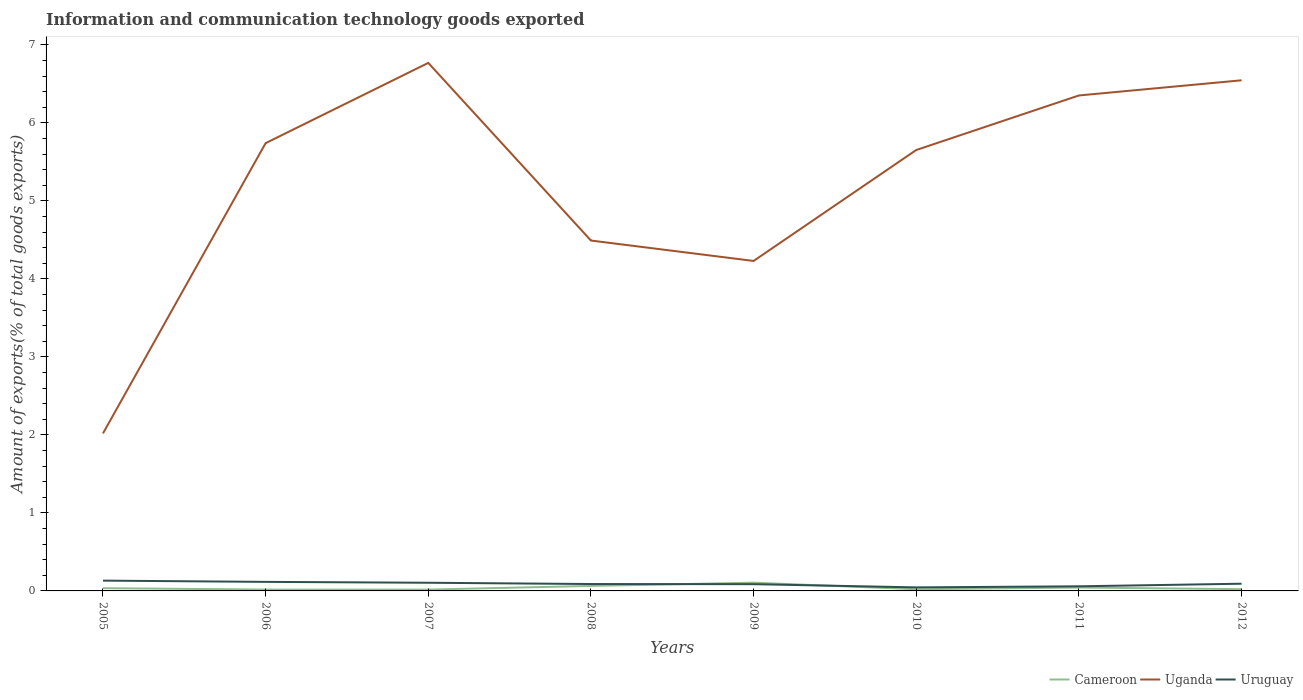How many different coloured lines are there?
Keep it short and to the point. 3. Does the line corresponding to Uganda intersect with the line corresponding to Uruguay?
Keep it short and to the point. No. Is the number of lines equal to the number of legend labels?
Provide a short and direct response. Yes. Across all years, what is the maximum amount of goods exported in Uruguay?
Provide a short and direct response. 0.05. In which year was the amount of goods exported in Cameroon maximum?
Ensure brevity in your answer.  2007. What is the total amount of goods exported in Cameroon in the graph?
Provide a succinct answer. 0. What is the difference between the highest and the second highest amount of goods exported in Uganda?
Make the answer very short. 4.75. What is the difference between the highest and the lowest amount of goods exported in Uruguay?
Your response must be concise. 4. Is the amount of goods exported in Cameroon strictly greater than the amount of goods exported in Uruguay over the years?
Provide a succinct answer. No. How many lines are there?
Your answer should be very brief. 3. How many years are there in the graph?
Ensure brevity in your answer.  8. Are the values on the major ticks of Y-axis written in scientific E-notation?
Your response must be concise. No. Does the graph contain grids?
Give a very brief answer. No. Where does the legend appear in the graph?
Keep it short and to the point. Bottom right. What is the title of the graph?
Your answer should be compact. Information and communication technology goods exported. What is the label or title of the Y-axis?
Ensure brevity in your answer.  Amount of exports(% of total goods exports). What is the Amount of exports(% of total goods exports) in Cameroon in 2005?
Offer a very short reply. 0.04. What is the Amount of exports(% of total goods exports) in Uganda in 2005?
Provide a short and direct response. 2.02. What is the Amount of exports(% of total goods exports) in Uruguay in 2005?
Keep it short and to the point. 0.13. What is the Amount of exports(% of total goods exports) in Cameroon in 2006?
Offer a terse response. 0.02. What is the Amount of exports(% of total goods exports) in Uganda in 2006?
Provide a succinct answer. 5.74. What is the Amount of exports(% of total goods exports) of Uruguay in 2006?
Make the answer very short. 0.12. What is the Amount of exports(% of total goods exports) of Cameroon in 2007?
Offer a terse response. 0.02. What is the Amount of exports(% of total goods exports) of Uganda in 2007?
Give a very brief answer. 6.77. What is the Amount of exports(% of total goods exports) in Uruguay in 2007?
Your answer should be very brief. 0.1. What is the Amount of exports(% of total goods exports) in Cameroon in 2008?
Your answer should be compact. 0.06. What is the Amount of exports(% of total goods exports) of Uganda in 2008?
Keep it short and to the point. 4.49. What is the Amount of exports(% of total goods exports) of Uruguay in 2008?
Make the answer very short. 0.09. What is the Amount of exports(% of total goods exports) of Cameroon in 2009?
Your answer should be compact. 0.11. What is the Amount of exports(% of total goods exports) in Uganda in 2009?
Your answer should be compact. 4.23. What is the Amount of exports(% of total goods exports) in Uruguay in 2009?
Your answer should be compact. 0.09. What is the Amount of exports(% of total goods exports) in Cameroon in 2010?
Offer a terse response. 0.02. What is the Amount of exports(% of total goods exports) of Uganda in 2010?
Give a very brief answer. 5.65. What is the Amount of exports(% of total goods exports) of Uruguay in 2010?
Offer a terse response. 0.05. What is the Amount of exports(% of total goods exports) in Cameroon in 2011?
Provide a short and direct response. 0.04. What is the Amount of exports(% of total goods exports) of Uganda in 2011?
Provide a short and direct response. 6.35. What is the Amount of exports(% of total goods exports) in Uruguay in 2011?
Your response must be concise. 0.06. What is the Amount of exports(% of total goods exports) of Cameroon in 2012?
Offer a very short reply. 0.02. What is the Amount of exports(% of total goods exports) of Uganda in 2012?
Your answer should be compact. 6.55. What is the Amount of exports(% of total goods exports) of Uruguay in 2012?
Ensure brevity in your answer.  0.09. Across all years, what is the maximum Amount of exports(% of total goods exports) in Cameroon?
Give a very brief answer. 0.11. Across all years, what is the maximum Amount of exports(% of total goods exports) in Uganda?
Provide a short and direct response. 6.77. Across all years, what is the maximum Amount of exports(% of total goods exports) of Uruguay?
Keep it short and to the point. 0.13. Across all years, what is the minimum Amount of exports(% of total goods exports) of Cameroon?
Your answer should be compact. 0.02. Across all years, what is the minimum Amount of exports(% of total goods exports) in Uganda?
Offer a terse response. 2.02. Across all years, what is the minimum Amount of exports(% of total goods exports) of Uruguay?
Your answer should be compact. 0.05. What is the total Amount of exports(% of total goods exports) in Cameroon in the graph?
Your response must be concise. 0.33. What is the total Amount of exports(% of total goods exports) of Uganda in the graph?
Your response must be concise. 41.8. What is the total Amount of exports(% of total goods exports) in Uruguay in the graph?
Offer a very short reply. 0.72. What is the difference between the Amount of exports(% of total goods exports) of Cameroon in 2005 and that in 2006?
Keep it short and to the point. 0.02. What is the difference between the Amount of exports(% of total goods exports) in Uganda in 2005 and that in 2006?
Offer a very short reply. -3.72. What is the difference between the Amount of exports(% of total goods exports) in Uruguay in 2005 and that in 2006?
Ensure brevity in your answer.  0.02. What is the difference between the Amount of exports(% of total goods exports) of Cameroon in 2005 and that in 2007?
Provide a short and direct response. 0.02. What is the difference between the Amount of exports(% of total goods exports) in Uganda in 2005 and that in 2007?
Make the answer very short. -4.75. What is the difference between the Amount of exports(% of total goods exports) in Uruguay in 2005 and that in 2007?
Offer a very short reply. 0.03. What is the difference between the Amount of exports(% of total goods exports) in Cameroon in 2005 and that in 2008?
Give a very brief answer. -0.03. What is the difference between the Amount of exports(% of total goods exports) of Uganda in 2005 and that in 2008?
Keep it short and to the point. -2.47. What is the difference between the Amount of exports(% of total goods exports) of Uruguay in 2005 and that in 2008?
Offer a very short reply. 0.04. What is the difference between the Amount of exports(% of total goods exports) in Cameroon in 2005 and that in 2009?
Keep it short and to the point. -0.07. What is the difference between the Amount of exports(% of total goods exports) of Uganda in 2005 and that in 2009?
Keep it short and to the point. -2.21. What is the difference between the Amount of exports(% of total goods exports) of Uruguay in 2005 and that in 2009?
Provide a succinct answer. 0.05. What is the difference between the Amount of exports(% of total goods exports) in Cameroon in 2005 and that in 2010?
Offer a very short reply. 0.01. What is the difference between the Amount of exports(% of total goods exports) of Uganda in 2005 and that in 2010?
Provide a short and direct response. -3.63. What is the difference between the Amount of exports(% of total goods exports) in Uruguay in 2005 and that in 2010?
Offer a terse response. 0.09. What is the difference between the Amount of exports(% of total goods exports) of Cameroon in 2005 and that in 2011?
Offer a very short reply. -0.01. What is the difference between the Amount of exports(% of total goods exports) of Uganda in 2005 and that in 2011?
Your answer should be very brief. -4.33. What is the difference between the Amount of exports(% of total goods exports) of Uruguay in 2005 and that in 2011?
Provide a short and direct response. 0.07. What is the difference between the Amount of exports(% of total goods exports) in Cameroon in 2005 and that in 2012?
Give a very brief answer. 0.01. What is the difference between the Amount of exports(% of total goods exports) in Uganda in 2005 and that in 2012?
Keep it short and to the point. -4.53. What is the difference between the Amount of exports(% of total goods exports) in Uruguay in 2005 and that in 2012?
Your response must be concise. 0.04. What is the difference between the Amount of exports(% of total goods exports) in Uganda in 2006 and that in 2007?
Offer a terse response. -1.03. What is the difference between the Amount of exports(% of total goods exports) of Uruguay in 2006 and that in 2007?
Keep it short and to the point. 0.01. What is the difference between the Amount of exports(% of total goods exports) of Cameroon in 2006 and that in 2008?
Keep it short and to the point. -0.05. What is the difference between the Amount of exports(% of total goods exports) of Uganda in 2006 and that in 2008?
Provide a succinct answer. 1.25. What is the difference between the Amount of exports(% of total goods exports) in Uruguay in 2006 and that in 2008?
Your answer should be compact. 0.03. What is the difference between the Amount of exports(% of total goods exports) in Cameroon in 2006 and that in 2009?
Give a very brief answer. -0.09. What is the difference between the Amount of exports(% of total goods exports) in Uganda in 2006 and that in 2009?
Your answer should be compact. 1.51. What is the difference between the Amount of exports(% of total goods exports) of Uruguay in 2006 and that in 2009?
Give a very brief answer. 0.03. What is the difference between the Amount of exports(% of total goods exports) in Cameroon in 2006 and that in 2010?
Ensure brevity in your answer.  -0. What is the difference between the Amount of exports(% of total goods exports) in Uganda in 2006 and that in 2010?
Offer a very short reply. 0.09. What is the difference between the Amount of exports(% of total goods exports) in Uruguay in 2006 and that in 2010?
Your response must be concise. 0.07. What is the difference between the Amount of exports(% of total goods exports) of Cameroon in 2006 and that in 2011?
Make the answer very short. -0.03. What is the difference between the Amount of exports(% of total goods exports) in Uganda in 2006 and that in 2011?
Make the answer very short. -0.61. What is the difference between the Amount of exports(% of total goods exports) of Uruguay in 2006 and that in 2011?
Offer a terse response. 0.06. What is the difference between the Amount of exports(% of total goods exports) in Cameroon in 2006 and that in 2012?
Provide a short and direct response. -0.01. What is the difference between the Amount of exports(% of total goods exports) of Uganda in 2006 and that in 2012?
Ensure brevity in your answer.  -0.81. What is the difference between the Amount of exports(% of total goods exports) of Uruguay in 2006 and that in 2012?
Keep it short and to the point. 0.02. What is the difference between the Amount of exports(% of total goods exports) of Cameroon in 2007 and that in 2008?
Keep it short and to the point. -0.05. What is the difference between the Amount of exports(% of total goods exports) in Uganda in 2007 and that in 2008?
Your response must be concise. 2.28. What is the difference between the Amount of exports(% of total goods exports) of Uruguay in 2007 and that in 2008?
Offer a terse response. 0.02. What is the difference between the Amount of exports(% of total goods exports) of Cameroon in 2007 and that in 2009?
Ensure brevity in your answer.  -0.09. What is the difference between the Amount of exports(% of total goods exports) in Uganda in 2007 and that in 2009?
Your answer should be compact. 2.54. What is the difference between the Amount of exports(% of total goods exports) of Uruguay in 2007 and that in 2009?
Make the answer very short. 0.02. What is the difference between the Amount of exports(% of total goods exports) of Cameroon in 2007 and that in 2010?
Make the answer very short. -0. What is the difference between the Amount of exports(% of total goods exports) in Uganda in 2007 and that in 2010?
Your answer should be very brief. 1.12. What is the difference between the Amount of exports(% of total goods exports) in Uruguay in 2007 and that in 2010?
Give a very brief answer. 0.06. What is the difference between the Amount of exports(% of total goods exports) of Cameroon in 2007 and that in 2011?
Offer a very short reply. -0.03. What is the difference between the Amount of exports(% of total goods exports) of Uganda in 2007 and that in 2011?
Your answer should be compact. 0.42. What is the difference between the Amount of exports(% of total goods exports) of Uruguay in 2007 and that in 2011?
Make the answer very short. 0.05. What is the difference between the Amount of exports(% of total goods exports) in Cameroon in 2007 and that in 2012?
Keep it short and to the point. -0.01. What is the difference between the Amount of exports(% of total goods exports) in Uganda in 2007 and that in 2012?
Keep it short and to the point. 0.22. What is the difference between the Amount of exports(% of total goods exports) of Uruguay in 2007 and that in 2012?
Provide a short and direct response. 0.01. What is the difference between the Amount of exports(% of total goods exports) of Cameroon in 2008 and that in 2009?
Your answer should be very brief. -0.04. What is the difference between the Amount of exports(% of total goods exports) in Uganda in 2008 and that in 2009?
Offer a terse response. 0.26. What is the difference between the Amount of exports(% of total goods exports) of Uruguay in 2008 and that in 2009?
Make the answer very short. 0. What is the difference between the Amount of exports(% of total goods exports) in Cameroon in 2008 and that in 2010?
Provide a short and direct response. 0.04. What is the difference between the Amount of exports(% of total goods exports) in Uganda in 2008 and that in 2010?
Provide a succinct answer. -1.16. What is the difference between the Amount of exports(% of total goods exports) in Uruguay in 2008 and that in 2010?
Give a very brief answer. 0.04. What is the difference between the Amount of exports(% of total goods exports) in Cameroon in 2008 and that in 2011?
Provide a succinct answer. 0.02. What is the difference between the Amount of exports(% of total goods exports) of Uganda in 2008 and that in 2011?
Your answer should be very brief. -1.86. What is the difference between the Amount of exports(% of total goods exports) of Uruguay in 2008 and that in 2011?
Provide a succinct answer. 0.03. What is the difference between the Amount of exports(% of total goods exports) of Cameroon in 2008 and that in 2012?
Ensure brevity in your answer.  0.04. What is the difference between the Amount of exports(% of total goods exports) of Uganda in 2008 and that in 2012?
Offer a very short reply. -2.05. What is the difference between the Amount of exports(% of total goods exports) in Uruguay in 2008 and that in 2012?
Make the answer very short. -0. What is the difference between the Amount of exports(% of total goods exports) of Cameroon in 2009 and that in 2010?
Your response must be concise. 0.08. What is the difference between the Amount of exports(% of total goods exports) in Uganda in 2009 and that in 2010?
Provide a succinct answer. -1.42. What is the difference between the Amount of exports(% of total goods exports) in Uruguay in 2009 and that in 2010?
Offer a terse response. 0.04. What is the difference between the Amount of exports(% of total goods exports) of Cameroon in 2009 and that in 2011?
Your answer should be very brief. 0.06. What is the difference between the Amount of exports(% of total goods exports) of Uganda in 2009 and that in 2011?
Provide a short and direct response. -2.12. What is the difference between the Amount of exports(% of total goods exports) in Uruguay in 2009 and that in 2011?
Ensure brevity in your answer.  0.03. What is the difference between the Amount of exports(% of total goods exports) of Cameroon in 2009 and that in 2012?
Offer a very short reply. 0.08. What is the difference between the Amount of exports(% of total goods exports) of Uganda in 2009 and that in 2012?
Keep it short and to the point. -2.32. What is the difference between the Amount of exports(% of total goods exports) in Uruguay in 2009 and that in 2012?
Ensure brevity in your answer.  -0.01. What is the difference between the Amount of exports(% of total goods exports) of Cameroon in 2010 and that in 2011?
Your answer should be compact. -0.02. What is the difference between the Amount of exports(% of total goods exports) in Uganda in 2010 and that in 2011?
Offer a terse response. -0.7. What is the difference between the Amount of exports(% of total goods exports) in Uruguay in 2010 and that in 2011?
Make the answer very short. -0.01. What is the difference between the Amount of exports(% of total goods exports) in Cameroon in 2010 and that in 2012?
Provide a succinct answer. -0. What is the difference between the Amount of exports(% of total goods exports) of Uganda in 2010 and that in 2012?
Ensure brevity in your answer.  -0.89. What is the difference between the Amount of exports(% of total goods exports) of Uruguay in 2010 and that in 2012?
Your response must be concise. -0.05. What is the difference between the Amount of exports(% of total goods exports) of Cameroon in 2011 and that in 2012?
Make the answer very short. 0.02. What is the difference between the Amount of exports(% of total goods exports) in Uganda in 2011 and that in 2012?
Make the answer very short. -0.19. What is the difference between the Amount of exports(% of total goods exports) of Uruguay in 2011 and that in 2012?
Provide a short and direct response. -0.03. What is the difference between the Amount of exports(% of total goods exports) in Cameroon in 2005 and the Amount of exports(% of total goods exports) in Uganda in 2006?
Your response must be concise. -5.71. What is the difference between the Amount of exports(% of total goods exports) in Cameroon in 2005 and the Amount of exports(% of total goods exports) in Uruguay in 2006?
Ensure brevity in your answer.  -0.08. What is the difference between the Amount of exports(% of total goods exports) of Uganda in 2005 and the Amount of exports(% of total goods exports) of Uruguay in 2006?
Offer a terse response. 1.9. What is the difference between the Amount of exports(% of total goods exports) in Cameroon in 2005 and the Amount of exports(% of total goods exports) in Uganda in 2007?
Offer a terse response. -6.73. What is the difference between the Amount of exports(% of total goods exports) of Cameroon in 2005 and the Amount of exports(% of total goods exports) of Uruguay in 2007?
Offer a terse response. -0.07. What is the difference between the Amount of exports(% of total goods exports) in Uganda in 2005 and the Amount of exports(% of total goods exports) in Uruguay in 2007?
Make the answer very short. 1.91. What is the difference between the Amount of exports(% of total goods exports) of Cameroon in 2005 and the Amount of exports(% of total goods exports) of Uganda in 2008?
Provide a succinct answer. -4.46. What is the difference between the Amount of exports(% of total goods exports) in Cameroon in 2005 and the Amount of exports(% of total goods exports) in Uruguay in 2008?
Provide a short and direct response. -0.05. What is the difference between the Amount of exports(% of total goods exports) of Uganda in 2005 and the Amount of exports(% of total goods exports) of Uruguay in 2008?
Ensure brevity in your answer.  1.93. What is the difference between the Amount of exports(% of total goods exports) of Cameroon in 2005 and the Amount of exports(% of total goods exports) of Uganda in 2009?
Give a very brief answer. -4.2. What is the difference between the Amount of exports(% of total goods exports) in Cameroon in 2005 and the Amount of exports(% of total goods exports) in Uruguay in 2009?
Keep it short and to the point. -0.05. What is the difference between the Amount of exports(% of total goods exports) in Uganda in 2005 and the Amount of exports(% of total goods exports) in Uruguay in 2009?
Your response must be concise. 1.93. What is the difference between the Amount of exports(% of total goods exports) of Cameroon in 2005 and the Amount of exports(% of total goods exports) of Uganda in 2010?
Provide a succinct answer. -5.62. What is the difference between the Amount of exports(% of total goods exports) of Cameroon in 2005 and the Amount of exports(% of total goods exports) of Uruguay in 2010?
Your response must be concise. -0.01. What is the difference between the Amount of exports(% of total goods exports) of Uganda in 2005 and the Amount of exports(% of total goods exports) of Uruguay in 2010?
Provide a succinct answer. 1.97. What is the difference between the Amount of exports(% of total goods exports) of Cameroon in 2005 and the Amount of exports(% of total goods exports) of Uganda in 2011?
Your answer should be very brief. -6.32. What is the difference between the Amount of exports(% of total goods exports) of Cameroon in 2005 and the Amount of exports(% of total goods exports) of Uruguay in 2011?
Ensure brevity in your answer.  -0.02. What is the difference between the Amount of exports(% of total goods exports) in Uganda in 2005 and the Amount of exports(% of total goods exports) in Uruguay in 2011?
Keep it short and to the point. 1.96. What is the difference between the Amount of exports(% of total goods exports) in Cameroon in 2005 and the Amount of exports(% of total goods exports) in Uganda in 2012?
Provide a short and direct response. -6.51. What is the difference between the Amount of exports(% of total goods exports) in Cameroon in 2005 and the Amount of exports(% of total goods exports) in Uruguay in 2012?
Offer a very short reply. -0.06. What is the difference between the Amount of exports(% of total goods exports) in Uganda in 2005 and the Amount of exports(% of total goods exports) in Uruguay in 2012?
Offer a terse response. 1.93. What is the difference between the Amount of exports(% of total goods exports) of Cameroon in 2006 and the Amount of exports(% of total goods exports) of Uganda in 2007?
Your answer should be compact. -6.75. What is the difference between the Amount of exports(% of total goods exports) in Cameroon in 2006 and the Amount of exports(% of total goods exports) in Uruguay in 2007?
Give a very brief answer. -0.09. What is the difference between the Amount of exports(% of total goods exports) of Uganda in 2006 and the Amount of exports(% of total goods exports) of Uruguay in 2007?
Offer a very short reply. 5.64. What is the difference between the Amount of exports(% of total goods exports) in Cameroon in 2006 and the Amount of exports(% of total goods exports) in Uganda in 2008?
Make the answer very short. -4.47. What is the difference between the Amount of exports(% of total goods exports) of Cameroon in 2006 and the Amount of exports(% of total goods exports) of Uruguay in 2008?
Your answer should be very brief. -0.07. What is the difference between the Amount of exports(% of total goods exports) of Uganda in 2006 and the Amount of exports(% of total goods exports) of Uruguay in 2008?
Your answer should be very brief. 5.65. What is the difference between the Amount of exports(% of total goods exports) in Cameroon in 2006 and the Amount of exports(% of total goods exports) in Uganda in 2009?
Your answer should be very brief. -4.21. What is the difference between the Amount of exports(% of total goods exports) of Cameroon in 2006 and the Amount of exports(% of total goods exports) of Uruguay in 2009?
Provide a succinct answer. -0.07. What is the difference between the Amount of exports(% of total goods exports) in Uganda in 2006 and the Amount of exports(% of total goods exports) in Uruguay in 2009?
Offer a terse response. 5.65. What is the difference between the Amount of exports(% of total goods exports) of Cameroon in 2006 and the Amount of exports(% of total goods exports) of Uganda in 2010?
Give a very brief answer. -5.64. What is the difference between the Amount of exports(% of total goods exports) of Cameroon in 2006 and the Amount of exports(% of total goods exports) of Uruguay in 2010?
Offer a very short reply. -0.03. What is the difference between the Amount of exports(% of total goods exports) in Uganda in 2006 and the Amount of exports(% of total goods exports) in Uruguay in 2010?
Offer a terse response. 5.7. What is the difference between the Amount of exports(% of total goods exports) in Cameroon in 2006 and the Amount of exports(% of total goods exports) in Uganda in 2011?
Give a very brief answer. -6.33. What is the difference between the Amount of exports(% of total goods exports) of Cameroon in 2006 and the Amount of exports(% of total goods exports) of Uruguay in 2011?
Provide a succinct answer. -0.04. What is the difference between the Amount of exports(% of total goods exports) in Uganda in 2006 and the Amount of exports(% of total goods exports) in Uruguay in 2011?
Make the answer very short. 5.68. What is the difference between the Amount of exports(% of total goods exports) in Cameroon in 2006 and the Amount of exports(% of total goods exports) in Uganda in 2012?
Make the answer very short. -6.53. What is the difference between the Amount of exports(% of total goods exports) of Cameroon in 2006 and the Amount of exports(% of total goods exports) of Uruguay in 2012?
Your answer should be very brief. -0.07. What is the difference between the Amount of exports(% of total goods exports) in Uganda in 2006 and the Amount of exports(% of total goods exports) in Uruguay in 2012?
Offer a terse response. 5.65. What is the difference between the Amount of exports(% of total goods exports) of Cameroon in 2007 and the Amount of exports(% of total goods exports) of Uganda in 2008?
Give a very brief answer. -4.48. What is the difference between the Amount of exports(% of total goods exports) in Cameroon in 2007 and the Amount of exports(% of total goods exports) in Uruguay in 2008?
Offer a very short reply. -0.07. What is the difference between the Amount of exports(% of total goods exports) of Uganda in 2007 and the Amount of exports(% of total goods exports) of Uruguay in 2008?
Your response must be concise. 6.68. What is the difference between the Amount of exports(% of total goods exports) of Cameroon in 2007 and the Amount of exports(% of total goods exports) of Uganda in 2009?
Give a very brief answer. -4.21. What is the difference between the Amount of exports(% of total goods exports) in Cameroon in 2007 and the Amount of exports(% of total goods exports) in Uruguay in 2009?
Your answer should be compact. -0.07. What is the difference between the Amount of exports(% of total goods exports) of Uganda in 2007 and the Amount of exports(% of total goods exports) of Uruguay in 2009?
Provide a short and direct response. 6.68. What is the difference between the Amount of exports(% of total goods exports) of Cameroon in 2007 and the Amount of exports(% of total goods exports) of Uganda in 2010?
Offer a very short reply. -5.64. What is the difference between the Amount of exports(% of total goods exports) of Cameroon in 2007 and the Amount of exports(% of total goods exports) of Uruguay in 2010?
Provide a short and direct response. -0.03. What is the difference between the Amount of exports(% of total goods exports) in Uganda in 2007 and the Amount of exports(% of total goods exports) in Uruguay in 2010?
Your answer should be very brief. 6.72. What is the difference between the Amount of exports(% of total goods exports) of Cameroon in 2007 and the Amount of exports(% of total goods exports) of Uganda in 2011?
Keep it short and to the point. -6.34. What is the difference between the Amount of exports(% of total goods exports) in Cameroon in 2007 and the Amount of exports(% of total goods exports) in Uruguay in 2011?
Your answer should be compact. -0.04. What is the difference between the Amount of exports(% of total goods exports) of Uganda in 2007 and the Amount of exports(% of total goods exports) of Uruguay in 2011?
Your answer should be compact. 6.71. What is the difference between the Amount of exports(% of total goods exports) of Cameroon in 2007 and the Amount of exports(% of total goods exports) of Uganda in 2012?
Make the answer very short. -6.53. What is the difference between the Amount of exports(% of total goods exports) of Cameroon in 2007 and the Amount of exports(% of total goods exports) of Uruguay in 2012?
Keep it short and to the point. -0.08. What is the difference between the Amount of exports(% of total goods exports) of Uganda in 2007 and the Amount of exports(% of total goods exports) of Uruguay in 2012?
Provide a short and direct response. 6.68. What is the difference between the Amount of exports(% of total goods exports) of Cameroon in 2008 and the Amount of exports(% of total goods exports) of Uganda in 2009?
Your answer should be compact. -4.17. What is the difference between the Amount of exports(% of total goods exports) of Cameroon in 2008 and the Amount of exports(% of total goods exports) of Uruguay in 2009?
Make the answer very short. -0.02. What is the difference between the Amount of exports(% of total goods exports) in Uganda in 2008 and the Amount of exports(% of total goods exports) in Uruguay in 2009?
Keep it short and to the point. 4.41. What is the difference between the Amount of exports(% of total goods exports) in Cameroon in 2008 and the Amount of exports(% of total goods exports) in Uganda in 2010?
Offer a very short reply. -5.59. What is the difference between the Amount of exports(% of total goods exports) of Cameroon in 2008 and the Amount of exports(% of total goods exports) of Uruguay in 2010?
Make the answer very short. 0.02. What is the difference between the Amount of exports(% of total goods exports) of Uganda in 2008 and the Amount of exports(% of total goods exports) of Uruguay in 2010?
Provide a succinct answer. 4.45. What is the difference between the Amount of exports(% of total goods exports) of Cameroon in 2008 and the Amount of exports(% of total goods exports) of Uganda in 2011?
Provide a succinct answer. -6.29. What is the difference between the Amount of exports(% of total goods exports) in Cameroon in 2008 and the Amount of exports(% of total goods exports) in Uruguay in 2011?
Your answer should be very brief. 0.01. What is the difference between the Amount of exports(% of total goods exports) in Uganda in 2008 and the Amount of exports(% of total goods exports) in Uruguay in 2011?
Provide a short and direct response. 4.43. What is the difference between the Amount of exports(% of total goods exports) in Cameroon in 2008 and the Amount of exports(% of total goods exports) in Uganda in 2012?
Your answer should be very brief. -6.48. What is the difference between the Amount of exports(% of total goods exports) in Cameroon in 2008 and the Amount of exports(% of total goods exports) in Uruguay in 2012?
Keep it short and to the point. -0.03. What is the difference between the Amount of exports(% of total goods exports) of Uganda in 2008 and the Amount of exports(% of total goods exports) of Uruguay in 2012?
Keep it short and to the point. 4.4. What is the difference between the Amount of exports(% of total goods exports) of Cameroon in 2009 and the Amount of exports(% of total goods exports) of Uganda in 2010?
Give a very brief answer. -5.55. What is the difference between the Amount of exports(% of total goods exports) in Cameroon in 2009 and the Amount of exports(% of total goods exports) in Uruguay in 2010?
Ensure brevity in your answer.  0.06. What is the difference between the Amount of exports(% of total goods exports) in Uganda in 2009 and the Amount of exports(% of total goods exports) in Uruguay in 2010?
Provide a succinct answer. 4.19. What is the difference between the Amount of exports(% of total goods exports) in Cameroon in 2009 and the Amount of exports(% of total goods exports) in Uganda in 2011?
Make the answer very short. -6.25. What is the difference between the Amount of exports(% of total goods exports) in Cameroon in 2009 and the Amount of exports(% of total goods exports) in Uruguay in 2011?
Ensure brevity in your answer.  0.05. What is the difference between the Amount of exports(% of total goods exports) in Uganda in 2009 and the Amount of exports(% of total goods exports) in Uruguay in 2011?
Make the answer very short. 4.17. What is the difference between the Amount of exports(% of total goods exports) in Cameroon in 2009 and the Amount of exports(% of total goods exports) in Uganda in 2012?
Your response must be concise. -6.44. What is the difference between the Amount of exports(% of total goods exports) of Cameroon in 2009 and the Amount of exports(% of total goods exports) of Uruguay in 2012?
Offer a terse response. 0.01. What is the difference between the Amount of exports(% of total goods exports) of Uganda in 2009 and the Amount of exports(% of total goods exports) of Uruguay in 2012?
Provide a succinct answer. 4.14. What is the difference between the Amount of exports(% of total goods exports) of Cameroon in 2010 and the Amount of exports(% of total goods exports) of Uganda in 2011?
Give a very brief answer. -6.33. What is the difference between the Amount of exports(% of total goods exports) of Cameroon in 2010 and the Amount of exports(% of total goods exports) of Uruguay in 2011?
Your answer should be very brief. -0.04. What is the difference between the Amount of exports(% of total goods exports) in Uganda in 2010 and the Amount of exports(% of total goods exports) in Uruguay in 2011?
Ensure brevity in your answer.  5.59. What is the difference between the Amount of exports(% of total goods exports) in Cameroon in 2010 and the Amount of exports(% of total goods exports) in Uganda in 2012?
Provide a short and direct response. -6.53. What is the difference between the Amount of exports(% of total goods exports) of Cameroon in 2010 and the Amount of exports(% of total goods exports) of Uruguay in 2012?
Keep it short and to the point. -0.07. What is the difference between the Amount of exports(% of total goods exports) of Uganda in 2010 and the Amount of exports(% of total goods exports) of Uruguay in 2012?
Make the answer very short. 5.56. What is the difference between the Amount of exports(% of total goods exports) of Cameroon in 2011 and the Amount of exports(% of total goods exports) of Uganda in 2012?
Your response must be concise. -6.5. What is the difference between the Amount of exports(% of total goods exports) of Cameroon in 2011 and the Amount of exports(% of total goods exports) of Uruguay in 2012?
Your answer should be very brief. -0.05. What is the difference between the Amount of exports(% of total goods exports) in Uganda in 2011 and the Amount of exports(% of total goods exports) in Uruguay in 2012?
Offer a very short reply. 6.26. What is the average Amount of exports(% of total goods exports) of Cameroon per year?
Provide a succinct answer. 0.04. What is the average Amount of exports(% of total goods exports) in Uganda per year?
Provide a short and direct response. 5.23. What is the average Amount of exports(% of total goods exports) of Uruguay per year?
Offer a very short reply. 0.09. In the year 2005, what is the difference between the Amount of exports(% of total goods exports) in Cameroon and Amount of exports(% of total goods exports) in Uganda?
Your response must be concise. -1.98. In the year 2005, what is the difference between the Amount of exports(% of total goods exports) in Cameroon and Amount of exports(% of total goods exports) in Uruguay?
Make the answer very short. -0.1. In the year 2005, what is the difference between the Amount of exports(% of total goods exports) in Uganda and Amount of exports(% of total goods exports) in Uruguay?
Keep it short and to the point. 1.89. In the year 2006, what is the difference between the Amount of exports(% of total goods exports) of Cameroon and Amount of exports(% of total goods exports) of Uganda?
Make the answer very short. -5.72. In the year 2006, what is the difference between the Amount of exports(% of total goods exports) in Cameroon and Amount of exports(% of total goods exports) in Uruguay?
Your answer should be very brief. -0.1. In the year 2006, what is the difference between the Amount of exports(% of total goods exports) in Uganda and Amount of exports(% of total goods exports) in Uruguay?
Provide a succinct answer. 5.62. In the year 2007, what is the difference between the Amount of exports(% of total goods exports) of Cameroon and Amount of exports(% of total goods exports) of Uganda?
Keep it short and to the point. -6.75. In the year 2007, what is the difference between the Amount of exports(% of total goods exports) of Cameroon and Amount of exports(% of total goods exports) of Uruguay?
Your response must be concise. -0.09. In the year 2007, what is the difference between the Amount of exports(% of total goods exports) of Uganda and Amount of exports(% of total goods exports) of Uruguay?
Ensure brevity in your answer.  6.66. In the year 2008, what is the difference between the Amount of exports(% of total goods exports) in Cameroon and Amount of exports(% of total goods exports) in Uganda?
Your answer should be compact. -4.43. In the year 2008, what is the difference between the Amount of exports(% of total goods exports) of Cameroon and Amount of exports(% of total goods exports) of Uruguay?
Your response must be concise. -0.02. In the year 2008, what is the difference between the Amount of exports(% of total goods exports) of Uganda and Amount of exports(% of total goods exports) of Uruguay?
Ensure brevity in your answer.  4.4. In the year 2009, what is the difference between the Amount of exports(% of total goods exports) of Cameroon and Amount of exports(% of total goods exports) of Uganda?
Provide a short and direct response. -4.12. In the year 2009, what is the difference between the Amount of exports(% of total goods exports) of Cameroon and Amount of exports(% of total goods exports) of Uruguay?
Your answer should be very brief. 0.02. In the year 2009, what is the difference between the Amount of exports(% of total goods exports) in Uganda and Amount of exports(% of total goods exports) in Uruguay?
Give a very brief answer. 4.14. In the year 2010, what is the difference between the Amount of exports(% of total goods exports) of Cameroon and Amount of exports(% of total goods exports) of Uganda?
Make the answer very short. -5.63. In the year 2010, what is the difference between the Amount of exports(% of total goods exports) of Cameroon and Amount of exports(% of total goods exports) of Uruguay?
Provide a succinct answer. -0.02. In the year 2010, what is the difference between the Amount of exports(% of total goods exports) of Uganda and Amount of exports(% of total goods exports) of Uruguay?
Offer a very short reply. 5.61. In the year 2011, what is the difference between the Amount of exports(% of total goods exports) of Cameroon and Amount of exports(% of total goods exports) of Uganda?
Give a very brief answer. -6.31. In the year 2011, what is the difference between the Amount of exports(% of total goods exports) in Cameroon and Amount of exports(% of total goods exports) in Uruguay?
Provide a succinct answer. -0.02. In the year 2011, what is the difference between the Amount of exports(% of total goods exports) in Uganda and Amount of exports(% of total goods exports) in Uruguay?
Make the answer very short. 6.29. In the year 2012, what is the difference between the Amount of exports(% of total goods exports) of Cameroon and Amount of exports(% of total goods exports) of Uganda?
Provide a short and direct response. -6.52. In the year 2012, what is the difference between the Amount of exports(% of total goods exports) of Cameroon and Amount of exports(% of total goods exports) of Uruguay?
Offer a terse response. -0.07. In the year 2012, what is the difference between the Amount of exports(% of total goods exports) in Uganda and Amount of exports(% of total goods exports) in Uruguay?
Offer a terse response. 6.45. What is the ratio of the Amount of exports(% of total goods exports) in Cameroon in 2005 to that in 2006?
Offer a very short reply. 2.01. What is the ratio of the Amount of exports(% of total goods exports) in Uganda in 2005 to that in 2006?
Make the answer very short. 0.35. What is the ratio of the Amount of exports(% of total goods exports) in Uruguay in 2005 to that in 2006?
Make the answer very short. 1.14. What is the ratio of the Amount of exports(% of total goods exports) of Cameroon in 2005 to that in 2007?
Your answer should be very brief. 2.07. What is the ratio of the Amount of exports(% of total goods exports) of Uganda in 2005 to that in 2007?
Your answer should be compact. 0.3. What is the ratio of the Amount of exports(% of total goods exports) of Uruguay in 2005 to that in 2007?
Offer a terse response. 1.26. What is the ratio of the Amount of exports(% of total goods exports) of Cameroon in 2005 to that in 2008?
Your answer should be very brief. 0.54. What is the ratio of the Amount of exports(% of total goods exports) of Uganda in 2005 to that in 2008?
Make the answer very short. 0.45. What is the ratio of the Amount of exports(% of total goods exports) of Uruguay in 2005 to that in 2008?
Offer a very short reply. 1.49. What is the ratio of the Amount of exports(% of total goods exports) of Cameroon in 2005 to that in 2009?
Ensure brevity in your answer.  0.33. What is the ratio of the Amount of exports(% of total goods exports) in Uganda in 2005 to that in 2009?
Offer a terse response. 0.48. What is the ratio of the Amount of exports(% of total goods exports) of Uruguay in 2005 to that in 2009?
Keep it short and to the point. 1.53. What is the ratio of the Amount of exports(% of total goods exports) of Cameroon in 2005 to that in 2010?
Ensure brevity in your answer.  1.63. What is the ratio of the Amount of exports(% of total goods exports) in Uganda in 2005 to that in 2010?
Ensure brevity in your answer.  0.36. What is the ratio of the Amount of exports(% of total goods exports) of Uruguay in 2005 to that in 2010?
Offer a terse response. 2.91. What is the ratio of the Amount of exports(% of total goods exports) of Cameroon in 2005 to that in 2011?
Give a very brief answer. 0.81. What is the ratio of the Amount of exports(% of total goods exports) in Uganda in 2005 to that in 2011?
Provide a short and direct response. 0.32. What is the ratio of the Amount of exports(% of total goods exports) in Uruguay in 2005 to that in 2011?
Your answer should be very brief. 2.23. What is the ratio of the Amount of exports(% of total goods exports) in Cameroon in 2005 to that in 2012?
Offer a terse response. 1.56. What is the ratio of the Amount of exports(% of total goods exports) in Uganda in 2005 to that in 2012?
Provide a succinct answer. 0.31. What is the ratio of the Amount of exports(% of total goods exports) in Uruguay in 2005 to that in 2012?
Your answer should be very brief. 1.43. What is the ratio of the Amount of exports(% of total goods exports) of Cameroon in 2006 to that in 2007?
Provide a succinct answer. 1.03. What is the ratio of the Amount of exports(% of total goods exports) of Uganda in 2006 to that in 2007?
Make the answer very short. 0.85. What is the ratio of the Amount of exports(% of total goods exports) of Uruguay in 2006 to that in 2007?
Offer a terse response. 1.11. What is the ratio of the Amount of exports(% of total goods exports) in Cameroon in 2006 to that in 2008?
Keep it short and to the point. 0.27. What is the ratio of the Amount of exports(% of total goods exports) of Uganda in 2006 to that in 2008?
Ensure brevity in your answer.  1.28. What is the ratio of the Amount of exports(% of total goods exports) in Uruguay in 2006 to that in 2008?
Offer a very short reply. 1.31. What is the ratio of the Amount of exports(% of total goods exports) in Cameroon in 2006 to that in 2009?
Give a very brief answer. 0.16. What is the ratio of the Amount of exports(% of total goods exports) of Uganda in 2006 to that in 2009?
Give a very brief answer. 1.36. What is the ratio of the Amount of exports(% of total goods exports) of Uruguay in 2006 to that in 2009?
Your answer should be very brief. 1.34. What is the ratio of the Amount of exports(% of total goods exports) of Cameroon in 2006 to that in 2010?
Ensure brevity in your answer.  0.81. What is the ratio of the Amount of exports(% of total goods exports) in Uganda in 2006 to that in 2010?
Give a very brief answer. 1.02. What is the ratio of the Amount of exports(% of total goods exports) of Uruguay in 2006 to that in 2010?
Provide a short and direct response. 2.56. What is the ratio of the Amount of exports(% of total goods exports) of Cameroon in 2006 to that in 2011?
Offer a terse response. 0.4. What is the ratio of the Amount of exports(% of total goods exports) of Uganda in 2006 to that in 2011?
Give a very brief answer. 0.9. What is the ratio of the Amount of exports(% of total goods exports) of Uruguay in 2006 to that in 2011?
Offer a very short reply. 1.97. What is the ratio of the Amount of exports(% of total goods exports) of Cameroon in 2006 to that in 2012?
Make the answer very short. 0.77. What is the ratio of the Amount of exports(% of total goods exports) in Uganda in 2006 to that in 2012?
Offer a very short reply. 0.88. What is the ratio of the Amount of exports(% of total goods exports) in Uruguay in 2006 to that in 2012?
Provide a short and direct response. 1.26. What is the ratio of the Amount of exports(% of total goods exports) in Cameroon in 2007 to that in 2008?
Make the answer very short. 0.26. What is the ratio of the Amount of exports(% of total goods exports) of Uganda in 2007 to that in 2008?
Provide a short and direct response. 1.51. What is the ratio of the Amount of exports(% of total goods exports) of Uruguay in 2007 to that in 2008?
Offer a very short reply. 1.19. What is the ratio of the Amount of exports(% of total goods exports) of Cameroon in 2007 to that in 2009?
Offer a terse response. 0.16. What is the ratio of the Amount of exports(% of total goods exports) in Uganda in 2007 to that in 2009?
Offer a very short reply. 1.6. What is the ratio of the Amount of exports(% of total goods exports) in Uruguay in 2007 to that in 2009?
Your answer should be very brief. 1.21. What is the ratio of the Amount of exports(% of total goods exports) in Cameroon in 2007 to that in 2010?
Your answer should be compact. 0.79. What is the ratio of the Amount of exports(% of total goods exports) of Uganda in 2007 to that in 2010?
Ensure brevity in your answer.  1.2. What is the ratio of the Amount of exports(% of total goods exports) in Uruguay in 2007 to that in 2010?
Provide a succinct answer. 2.31. What is the ratio of the Amount of exports(% of total goods exports) of Cameroon in 2007 to that in 2011?
Offer a terse response. 0.39. What is the ratio of the Amount of exports(% of total goods exports) in Uganda in 2007 to that in 2011?
Ensure brevity in your answer.  1.07. What is the ratio of the Amount of exports(% of total goods exports) in Uruguay in 2007 to that in 2011?
Ensure brevity in your answer.  1.77. What is the ratio of the Amount of exports(% of total goods exports) in Cameroon in 2007 to that in 2012?
Keep it short and to the point. 0.75. What is the ratio of the Amount of exports(% of total goods exports) in Uganda in 2007 to that in 2012?
Keep it short and to the point. 1.03. What is the ratio of the Amount of exports(% of total goods exports) in Uruguay in 2007 to that in 2012?
Your response must be concise. 1.13. What is the ratio of the Amount of exports(% of total goods exports) in Cameroon in 2008 to that in 2009?
Offer a very short reply. 0.61. What is the ratio of the Amount of exports(% of total goods exports) in Uganda in 2008 to that in 2009?
Your answer should be compact. 1.06. What is the ratio of the Amount of exports(% of total goods exports) in Uruguay in 2008 to that in 2009?
Ensure brevity in your answer.  1.02. What is the ratio of the Amount of exports(% of total goods exports) in Cameroon in 2008 to that in 2010?
Your response must be concise. 3. What is the ratio of the Amount of exports(% of total goods exports) of Uganda in 2008 to that in 2010?
Make the answer very short. 0.79. What is the ratio of the Amount of exports(% of total goods exports) of Uruguay in 2008 to that in 2010?
Ensure brevity in your answer.  1.95. What is the ratio of the Amount of exports(% of total goods exports) in Cameroon in 2008 to that in 2011?
Provide a succinct answer. 1.49. What is the ratio of the Amount of exports(% of total goods exports) in Uganda in 2008 to that in 2011?
Offer a very short reply. 0.71. What is the ratio of the Amount of exports(% of total goods exports) in Uruguay in 2008 to that in 2011?
Keep it short and to the point. 1.5. What is the ratio of the Amount of exports(% of total goods exports) in Cameroon in 2008 to that in 2012?
Make the answer very short. 2.86. What is the ratio of the Amount of exports(% of total goods exports) of Uganda in 2008 to that in 2012?
Offer a very short reply. 0.69. What is the ratio of the Amount of exports(% of total goods exports) in Uruguay in 2008 to that in 2012?
Ensure brevity in your answer.  0.96. What is the ratio of the Amount of exports(% of total goods exports) of Cameroon in 2009 to that in 2010?
Offer a very short reply. 4.93. What is the ratio of the Amount of exports(% of total goods exports) of Uganda in 2009 to that in 2010?
Ensure brevity in your answer.  0.75. What is the ratio of the Amount of exports(% of total goods exports) in Uruguay in 2009 to that in 2010?
Provide a short and direct response. 1.91. What is the ratio of the Amount of exports(% of total goods exports) in Cameroon in 2009 to that in 2011?
Provide a succinct answer. 2.45. What is the ratio of the Amount of exports(% of total goods exports) in Uganda in 2009 to that in 2011?
Offer a terse response. 0.67. What is the ratio of the Amount of exports(% of total goods exports) in Uruguay in 2009 to that in 2011?
Offer a very short reply. 1.46. What is the ratio of the Amount of exports(% of total goods exports) of Cameroon in 2009 to that in 2012?
Give a very brief answer. 4.7. What is the ratio of the Amount of exports(% of total goods exports) of Uganda in 2009 to that in 2012?
Keep it short and to the point. 0.65. What is the ratio of the Amount of exports(% of total goods exports) of Uruguay in 2009 to that in 2012?
Provide a short and direct response. 0.94. What is the ratio of the Amount of exports(% of total goods exports) in Cameroon in 2010 to that in 2011?
Offer a very short reply. 0.5. What is the ratio of the Amount of exports(% of total goods exports) in Uganda in 2010 to that in 2011?
Provide a succinct answer. 0.89. What is the ratio of the Amount of exports(% of total goods exports) in Uruguay in 2010 to that in 2011?
Your answer should be compact. 0.77. What is the ratio of the Amount of exports(% of total goods exports) of Cameroon in 2010 to that in 2012?
Ensure brevity in your answer.  0.95. What is the ratio of the Amount of exports(% of total goods exports) in Uganda in 2010 to that in 2012?
Give a very brief answer. 0.86. What is the ratio of the Amount of exports(% of total goods exports) of Uruguay in 2010 to that in 2012?
Make the answer very short. 0.49. What is the ratio of the Amount of exports(% of total goods exports) in Cameroon in 2011 to that in 2012?
Provide a succinct answer. 1.92. What is the ratio of the Amount of exports(% of total goods exports) in Uganda in 2011 to that in 2012?
Provide a succinct answer. 0.97. What is the ratio of the Amount of exports(% of total goods exports) of Uruguay in 2011 to that in 2012?
Offer a very short reply. 0.64. What is the difference between the highest and the second highest Amount of exports(% of total goods exports) in Cameroon?
Ensure brevity in your answer.  0.04. What is the difference between the highest and the second highest Amount of exports(% of total goods exports) in Uganda?
Give a very brief answer. 0.22. What is the difference between the highest and the second highest Amount of exports(% of total goods exports) in Uruguay?
Your response must be concise. 0.02. What is the difference between the highest and the lowest Amount of exports(% of total goods exports) in Cameroon?
Your response must be concise. 0.09. What is the difference between the highest and the lowest Amount of exports(% of total goods exports) in Uganda?
Your response must be concise. 4.75. What is the difference between the highest and the lowest Amount of exports(% of total goods exports) of Uruguay?
Keep it short and to the point. 0.09. 